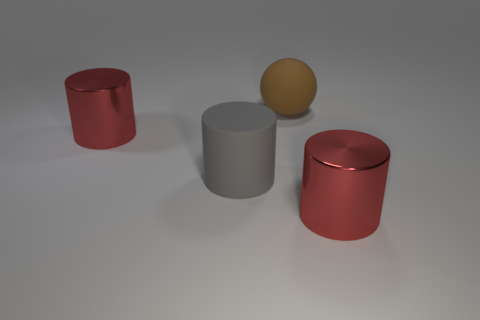Add 4 red things. How many objects exist? 8 Subtract all spheres. How many objects are left? 3 Add 1 gray rubber cylinders. How many gray rubber cylinders are left? 2 Add 1 shiny cylinders. How many shiny cylinders exist? 3 Subtract 0 yellow spheres. How many objects are left? 4 Subtract all big red objects. Subtract all big gray objects. How many objects are left? 1 